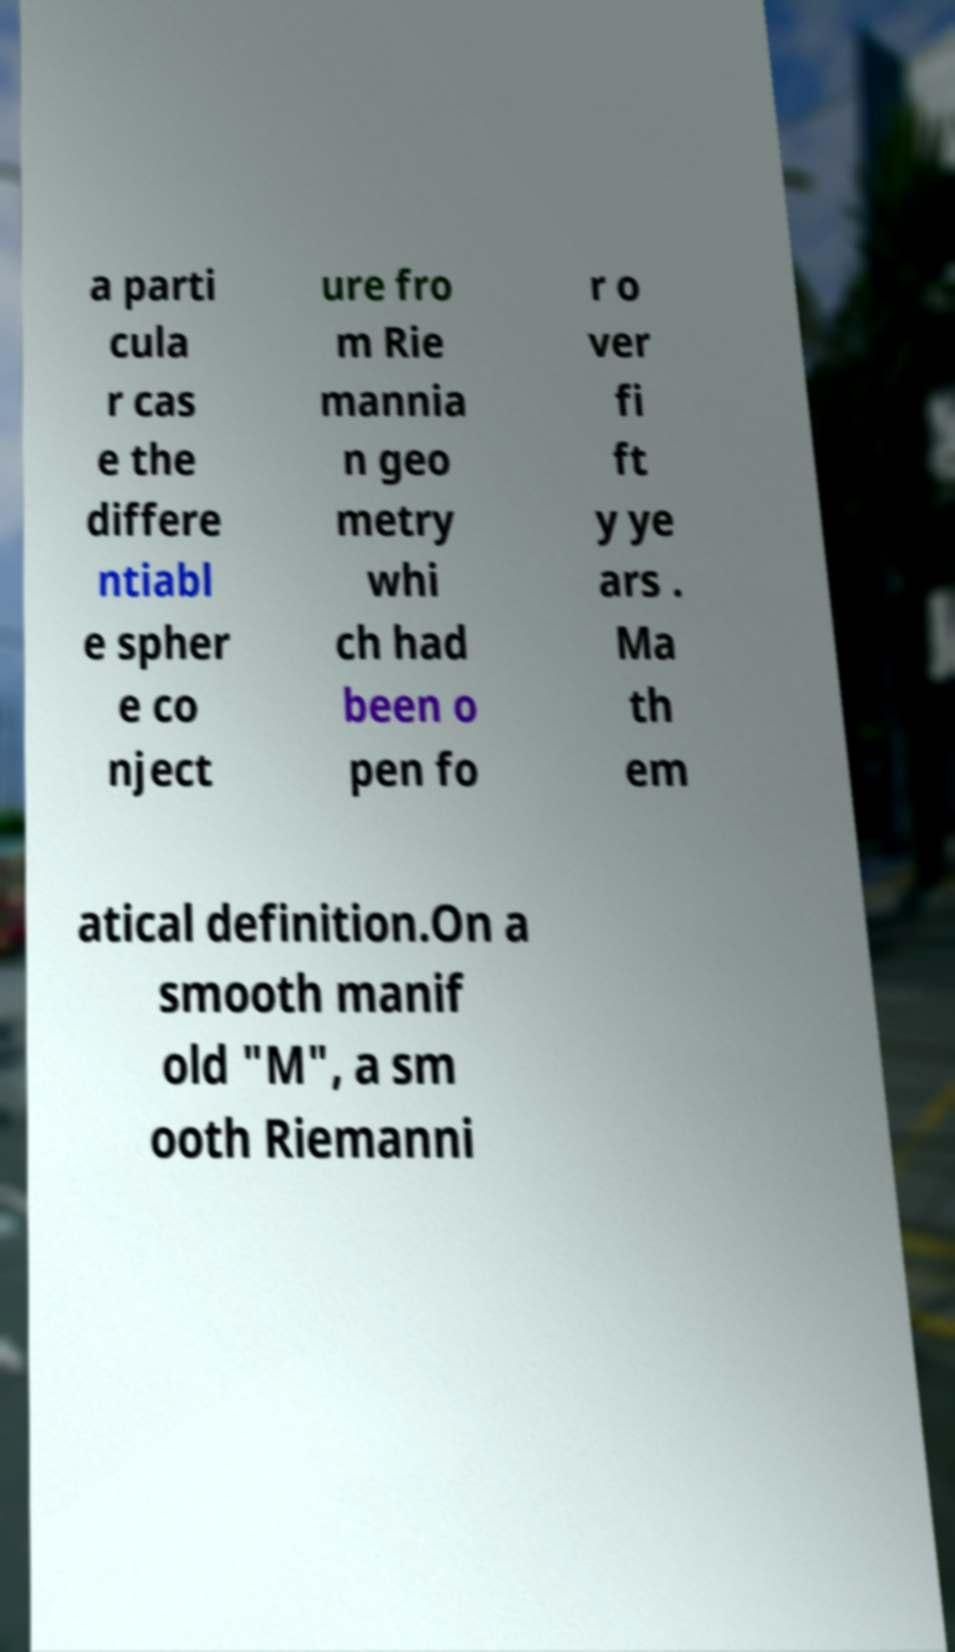Please read and relay the text visible in this image. What does it say? a parti cula r cas e the differe ntiabl e spher e co nject ure fro m Rie mannia n geo metry whi ch had been o pen fo r o ver fi ft y ye ars . Ma th em atical definition.On a smooth manif old "M", a sm ooth Riemanni 